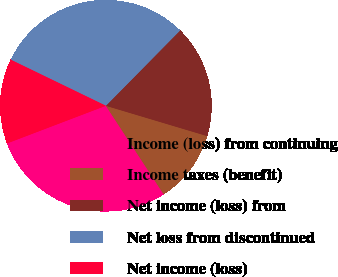<chart> <loc_0><loc_0><loc_500><loc_500><pie_chart><fcel>Income (loss) from continuing<fcel>Income taxes (benefit)<fcel>Net income (loss) from<fcel>Net loss from discontinued<fcel>Net income (loss)<nl><fcel>28.41%<fcel>11.17%<fcel>17.24%<fcel>30.21%<fcel>12.97%<nl></chart> 